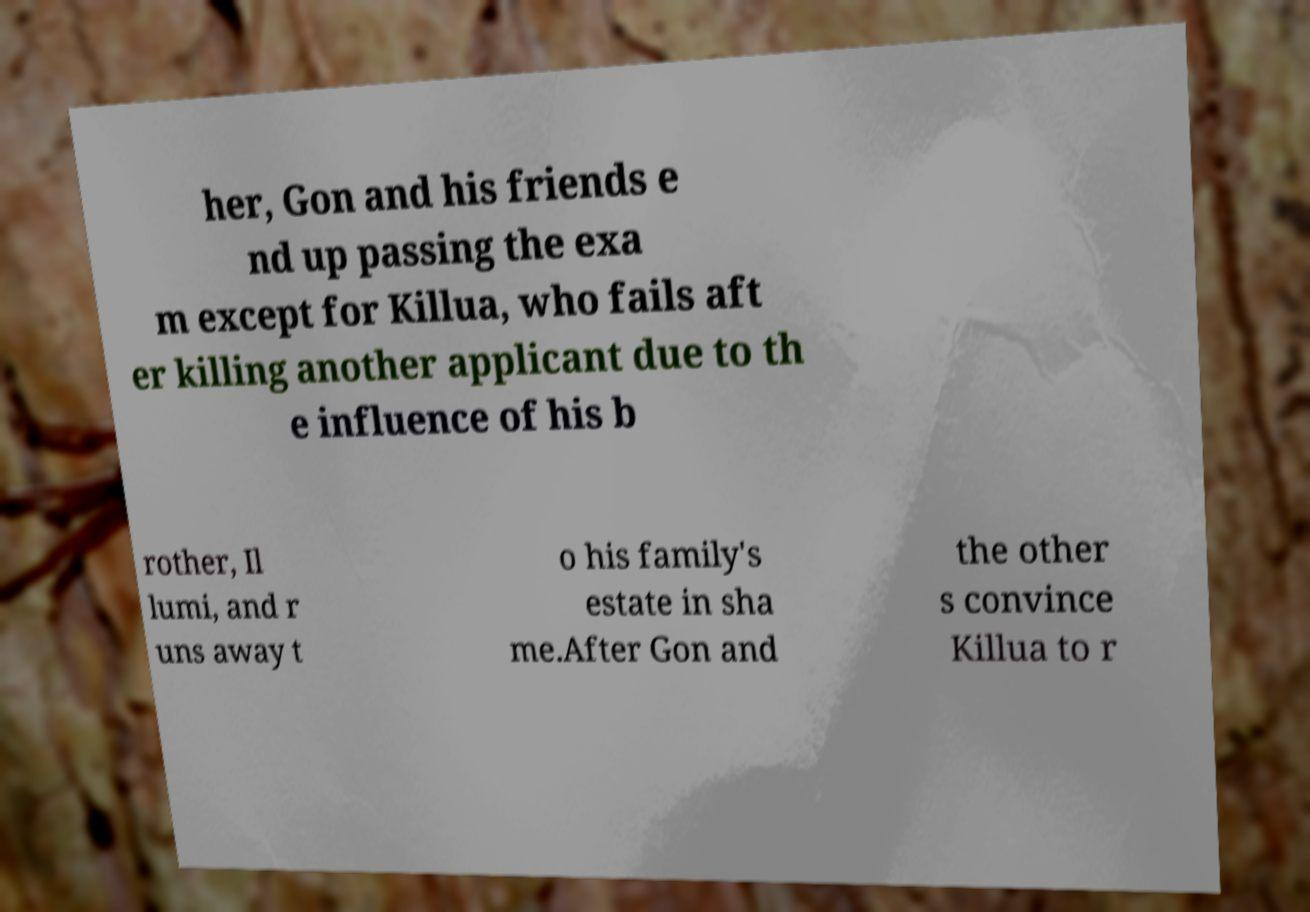Could you assist in decoding the text presented in this image and type it out clearly? her, Gon and his friends e nd up passing the exa m except for Killua, who fails aft er killing another applicant due to th e influence of his b rother, Il lumi, and r uns away t o his family's estate in sha me.After Gon and the other s convince Killua to r 